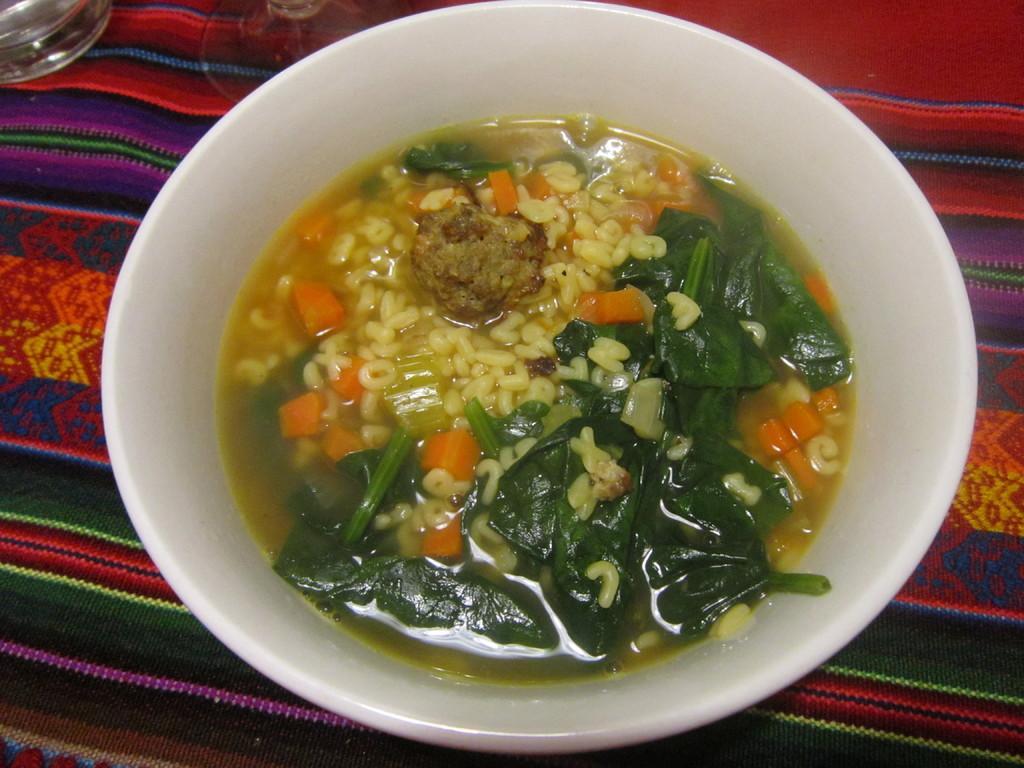Could you give a brief overview of what you see in this image? In this image there is a cup in the cup. Beside the cup there is a glass on the mat. 